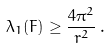<formula> <loc_0><loc_0><loc_500><loc_500>\lambda _ { 1 } ( F ) \geq \frac { 4 \pi ^ { 2 } } { r ^ { 2 } } \, .</formula> 